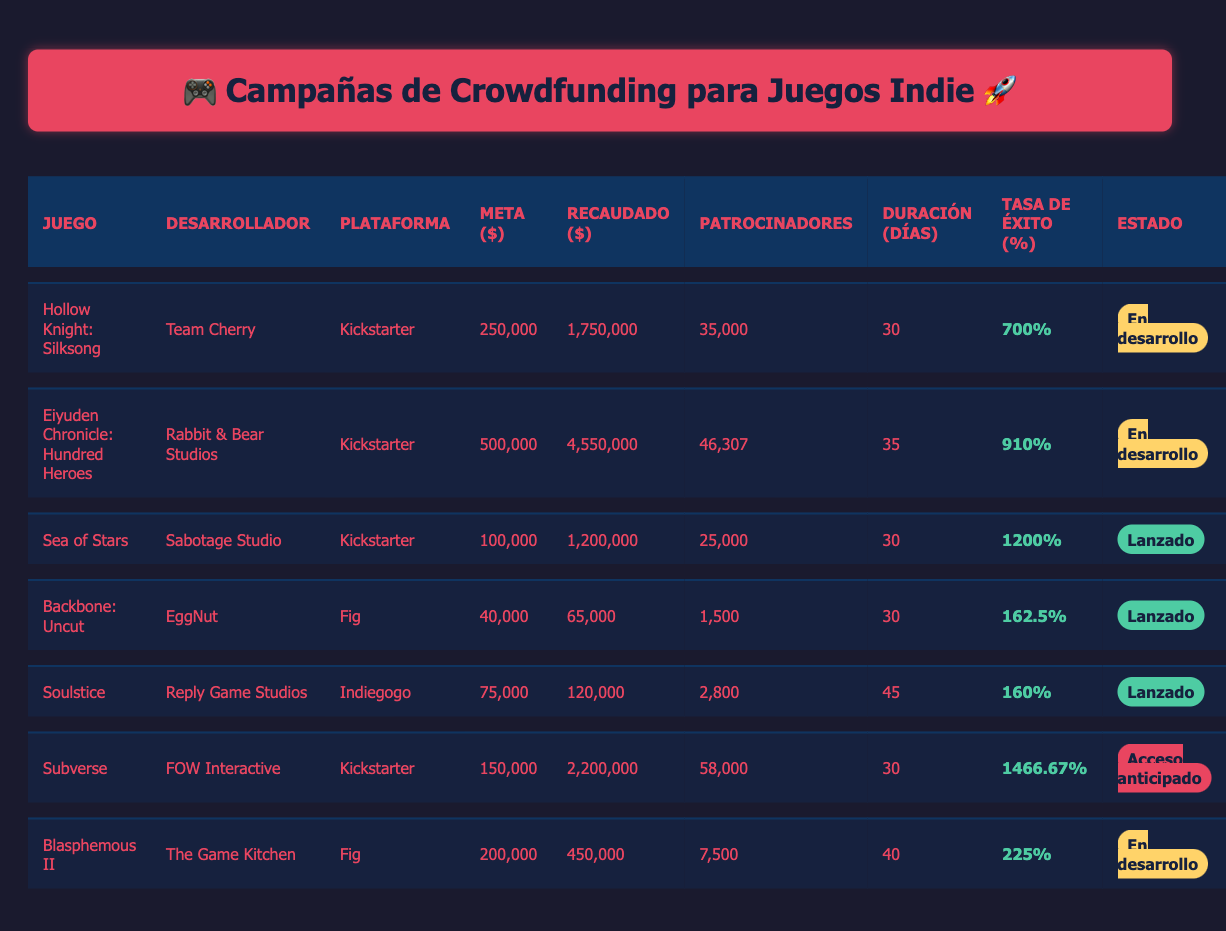¿Cuál es el juego con la tasa de éxito más alta? Al observar la tabla, "Sea of Stars" tiene una tasa de éxito de 1200%, que es la más alta entre todos los juegos listados.
Answer: Sea of Stars ¿Cuántos patrocinadores tuvo "Eiyuden Chronicle: Hundred Heroes"? La tabla indica que "Eiyuden Chronicle: Hundred Heroes" tuvo 46,307 patrocinadores.
Answer: 46,307 ¿Es "Hollow Knight: Silksong" un juego ya lanzado? La tabla muestra que "Hollow Knight: Silksong" está en desarrollo, por lo que no ha sido lanzado.
Answer: No ¿Cuál es la diferencia entre el monto recaudado de "Subverse" y su meta? "Subverse" recaudó 2,200,000 y su meta era 150,000. La diferencia es calculada restando la meta de la cantidad recaudada: 2,200,000 - 150,000 = 2,050,000.
Answer: 2,050,000 ¿Cuál es el promedio de patrocinadores entre los juegos que ya han sido lanzados? Los juegos lanzados son "Sea of Stars" (25,000), "Backbone: Uncut" (1,500), y "Soulstice" (2,800). Para calcular el promedio, primero sumamos: 25,000 + 1,500 + 2,800 = 29,300. Luego, dividimos por 3 (número de juegos lanzados): 29,300 / 3 = 9,766.67.
Answer: 9,766.67 ¿Qué juego en la tabla tuvo el mayor monto recaudado y cuál fue ese monto? Al revisar todos los juegos, "Eiyuden Chronicle: Hundred Heroes" recaudó la mayor cantidad con 4,550,000.
Answer: Eiyuden Chronicle: Hundred Heroes, 4,550,000 ¿Cuántos días duró la campaña de "Blasphemous II"? La tabla especifica que la duración de la campaña de "Blasphemous II" fue de 40 días.
Answer: 40 días ¿Cuál fue el monto total recaudado entre todos los juegos en la campaña? Para obtener el monto total recaudado, sumamos todos los montos recaudados: 1,750,000 + 4,550,000 + 1,200,000 + 65,000 + 120,000 + 2,200,000 + 450,000 = 10,335,000.
Answer: 10,335,000 